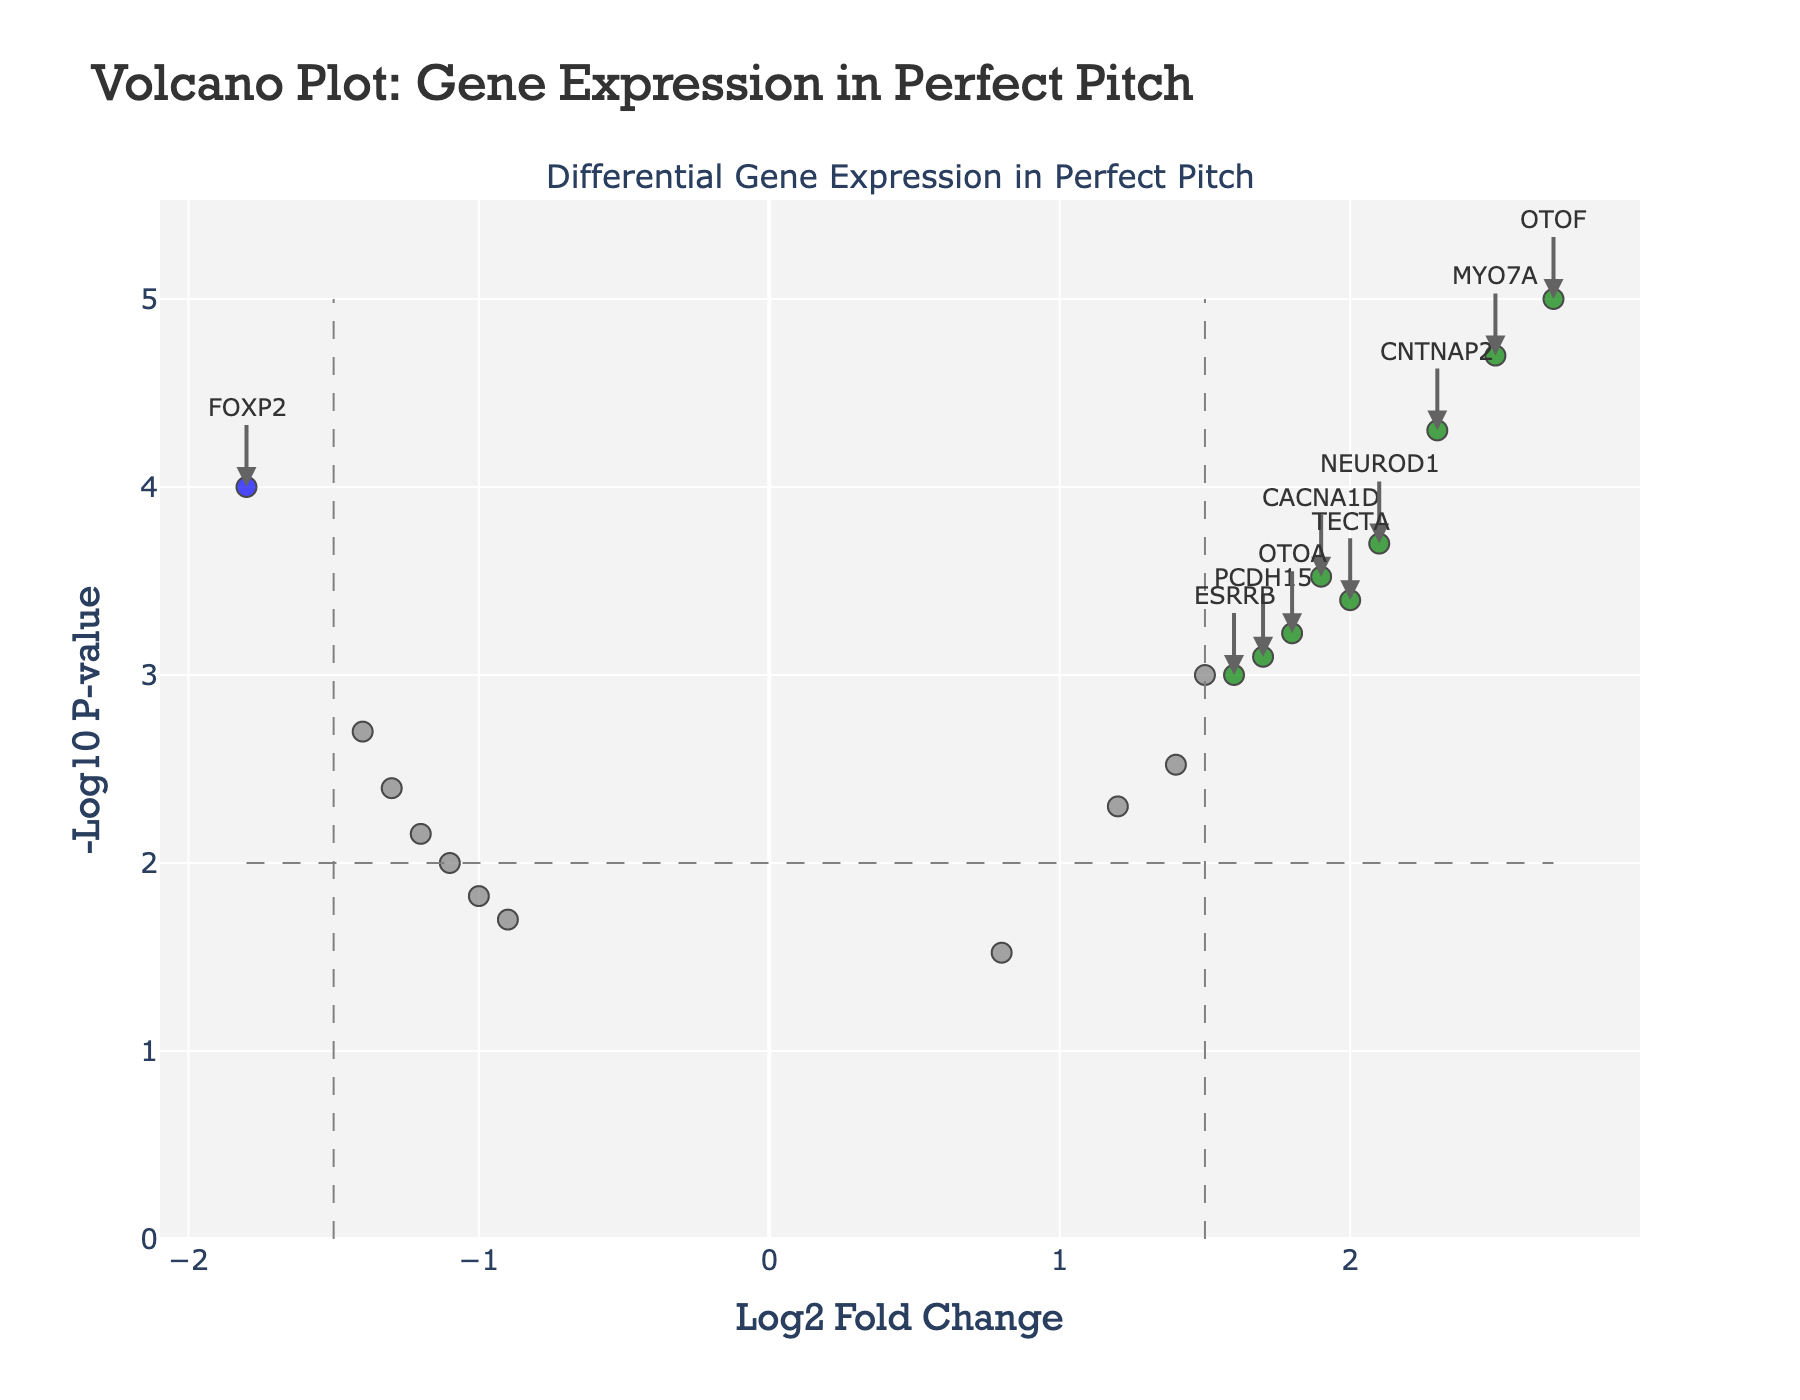What's the title of this plot? The title of the plot is located at the top and is labeled "Volcano Plot: Gene Expression in Perfect Pitch."
Answer: "Volcano Plot: Gene Expression in Perfect Pitch" What do the x and y axes represent? The x-axis represents the log2 fold change, which shows how much a gene’s expression level changes, while the y-axis represents the -log10 transformed p-values, indicating the statistical significance of the changes.
Answer: Log2 fold change and -Log10 P-value How many genes are significantly upregulated? Significant upregulation is indicated by points in green, located above the -log10 p-value threshold and having a log2 fold change greater than 1.5. In the plot, five genes are colored green.
Answer: 5 genes Which gene has the highest fold change? The highest fold change is represented by the gene with the most extreme positive value on the x-axis. Here, the gene marked as OTOF has the highest log2 fold change of 2.7.
Answer: OTOF Which gene has the lowest p-value? The lowest p-value corresponds to the highest -log10 p-value on the y-axis. The gene OTOF, positioned highest on the y-axis, has the lowest p-value.
Answer: OTOF Are there more upregulated or downregulated genes with significant changes? Upregulated genes have positive log2 fold changes, and downregulated genes have negative log2 fold changes. By counting the green points (5) and the blue points (5), the number of upregulated and downregulated genes is the same.
Answer: Same number Which color represents non-significant genes? Non-significant genes are coded with the color grey in the plot.
Answer: Grey Compare the fold changes of FOXP2 and CNTNAP2. Which is greater? The log2 fold change for FOXP2 is -1.8, and for CNTNAP2, it is 2.3. Since 2.3 is greater than -1.8, CNTNAP2 has a greater fold change.
Answer: CNTNAP2 Identify the gene with a log2 fold change of around -1 and its significance. A gene with a log2 fold change around -1 is KCNQ4. Since its p-value (0.015) is higher than the threshold (0.01), it is not considered significantly regulated.
Answer: KCNQ4 What is the log2 fold change and p-value for TECTA? By examining the plot, TECTA has a log2 fold change of 2.0 and a p-value of 0.0004.
Answer: 2.0 and 0.0004 